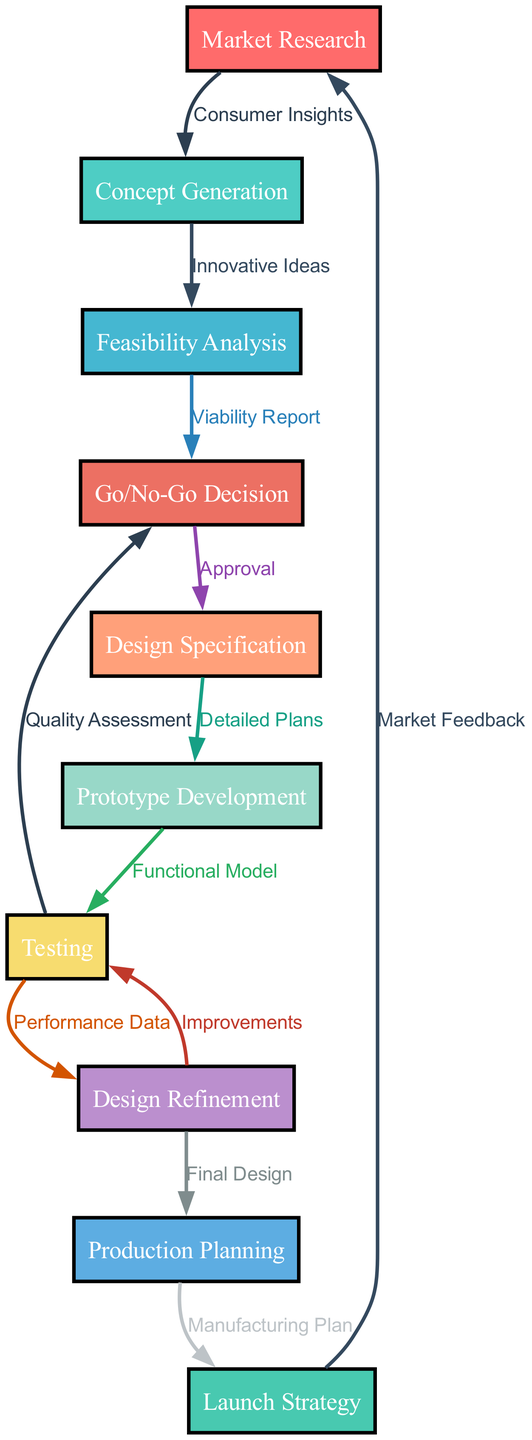What is the starting point of the process? The diagram indicates that "Market Research" is the first node, as it is not preceded by any other node.
Answer: Market Research How many nodes are present in the diagram? By counting all distinct process stages listed, there are ten nodes.
Answer: 10 What is the output of the "Feasibility Analysis"? The "Feasibility Analysis" node leads directly to the "Go/No-Go Decision" node, indicating it serves as the basis for this decision.
Answer: Go/No-Go Decision Which node receives feedback from the "Testing" node? The "Testing" node sends feedback to both "Design Refinement" and "Go/No-Go Decision", which are clearly connected by arrows in the diagram indicating feedback.
Answer: Design Refinement, Go/No-Go Decision What is the last step before the product launch? The "Launch Strategy" node comes immediately before implementation, indicating it is the final step in preparing for the launch phase.
Answer: Launch Strategy If the decision is 'Go', what is the next node? Following a 'Go' decision, the flow indicates it leads to "Design Specification", confirming it as the next step.
Answer: Design Specification What leads to the "Testing" phase? The "Prototype Development" phase feeds directly into "Testing", showing it as a prerequisite step for testing the prototype.
Answer: Prototype Development How is market feedback incorporated into the workflow? The "Launch Strategy" node loops back to "Market Research", showing that feedback from the launch phase is utilized for future market research.
Answer: Market Research What does "Design Refinement" depend on? "Design Refinement" relies on inputs from both "Testing" and outputs from itself, as indicated by the arrows directing toward it and back following improvements.
Answer: Testing 